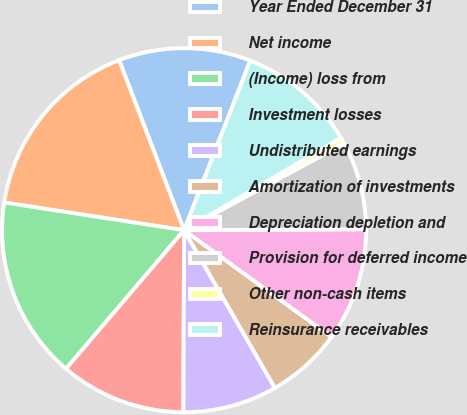Convert chart to OTSL. <chart><loc_0><loc_0><loc_500><loc_500><pie_chart><fcel>Year Ended December 31<fcel>Net income<fcel>(Income) loss from<fcel>Investment losses<fcel>Undistributed earnings<fcel>Amortization of investments<fcel>Depreciation depletion and<fcel>Provision for deferred income<fcel>Other non-cash items<fcel>Reinsurance receivables<nl><fcel>11.73%<fcel>16.76%<fcel>16.2%<fcel>11.17%<fcel>8.38%<fcel>6.71%<fcel>10.06%<fcel>7.82%<fcel>0.56%<fcel>10.61%<nl></chart> 